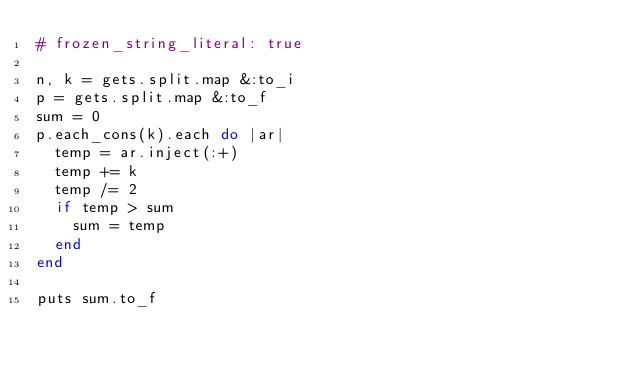Convert code to text. <code><loc_0><loc_0><loc_500><loc_500><_Ruby_># frozen_string_literal: true

n, k = gets.split.map &:to_i
p = gets.split.map &:to_f
sum = 0
p.each_cons(k).each do |ar|
  temp = ar.inject(:+)
  temp += k
  temp /= 2
  if temp > sum
    sum = temp
  end
end

puts sum.to_f
</code> 